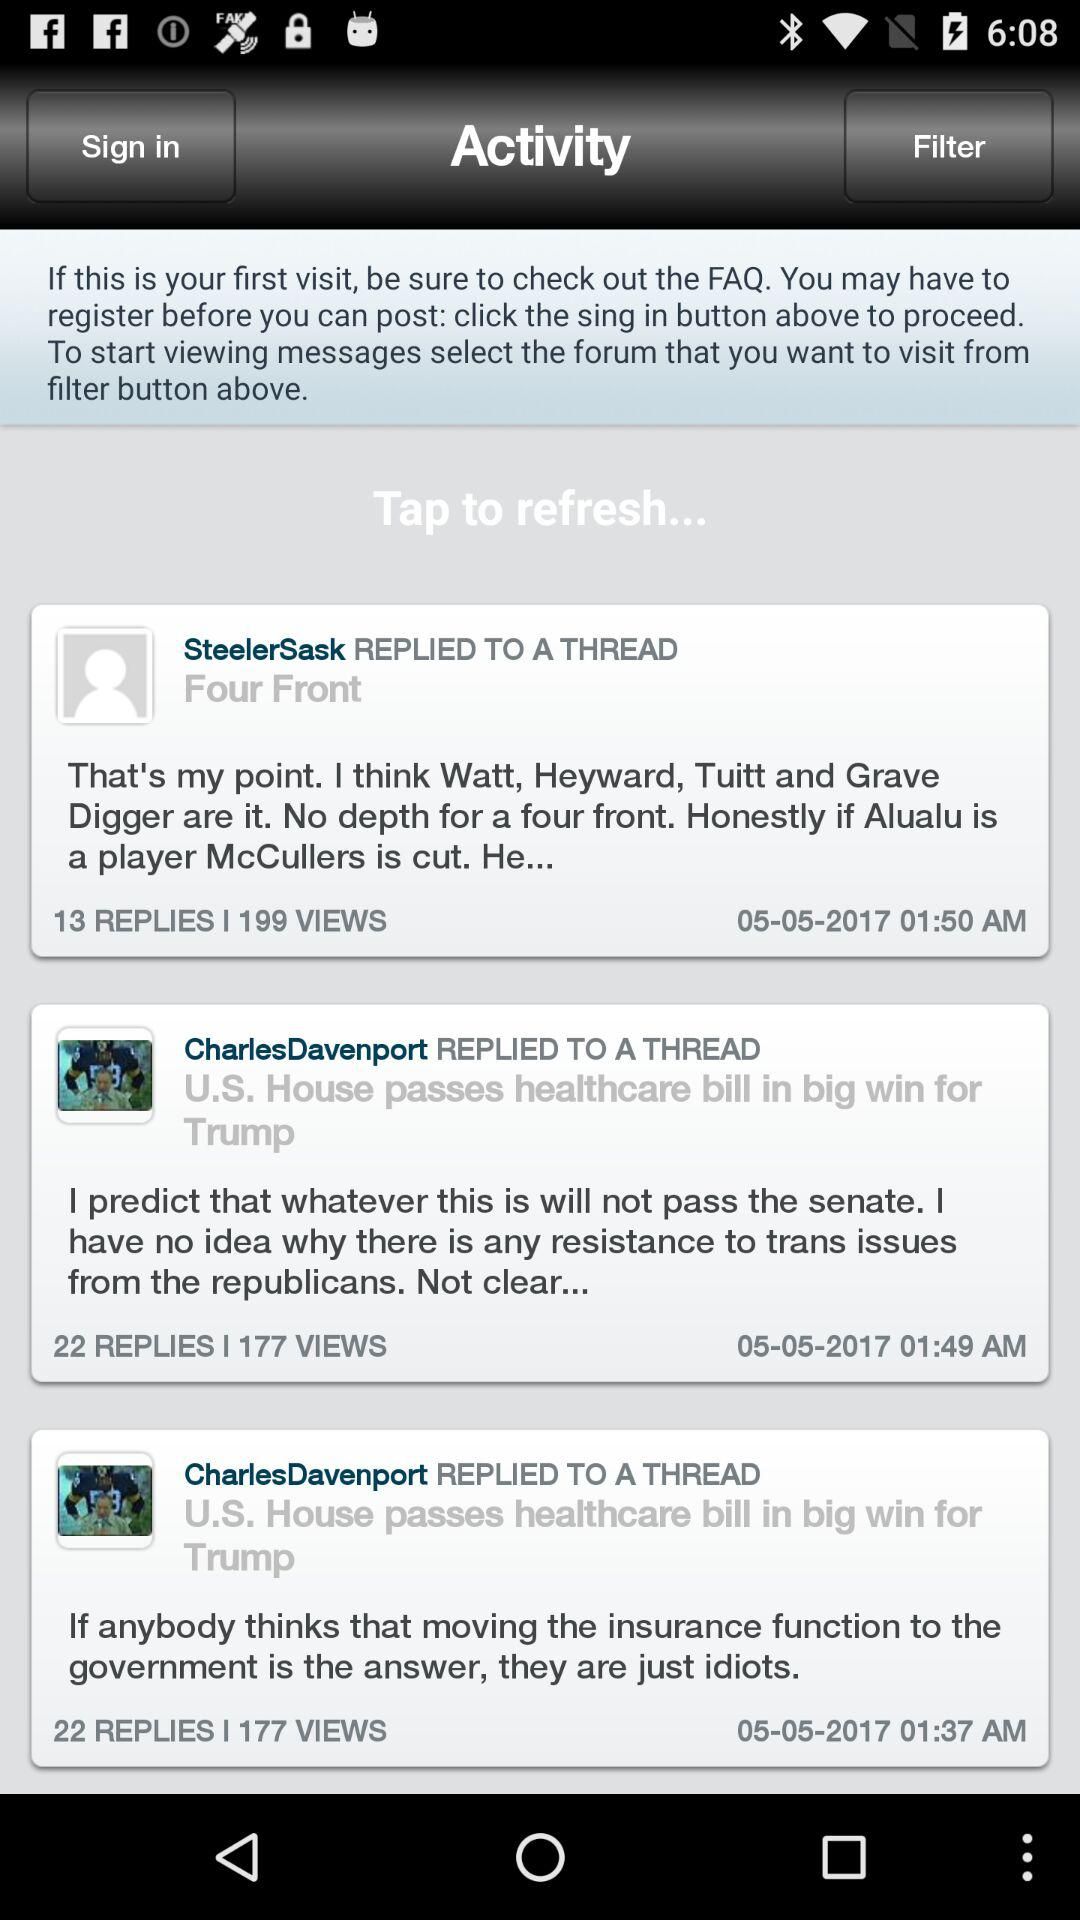When was SteelerSask's reply to the thread? SteelerSask replied to the thread on 05-05-2017 at 01:50 AM. 